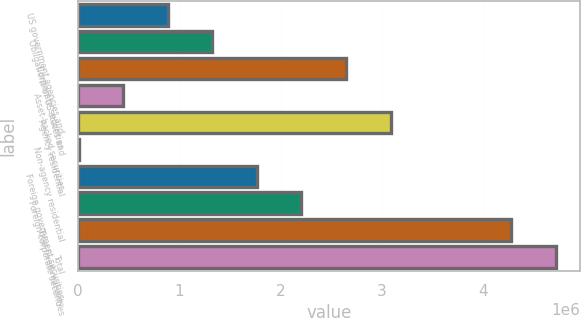Convert chart. <chart><loc_0><loc_0><loc_500><loc_500><bar_chart><fcel>US government agencies and<fcel>Obligations of US states and<fcel>Corporate securities<fcel>Asset-backed securities<fcel>Agency residential<fcel>Non-agency residential<fcel>Foreign government securities<fcel>Foreign corporate securities<fcel>Total fixed maturity<fcel>Total<nl><fcel>883472<fcel>1.32356e+06<fcel>2.64382e+06<fcel>443386<fcel>3.08391e+06<fcel>3299<fcel>1.76365e+06<fcel>2.20373e+06<fcel>4.27714e+06<fcel>4.71722e+06<nl></chart> 